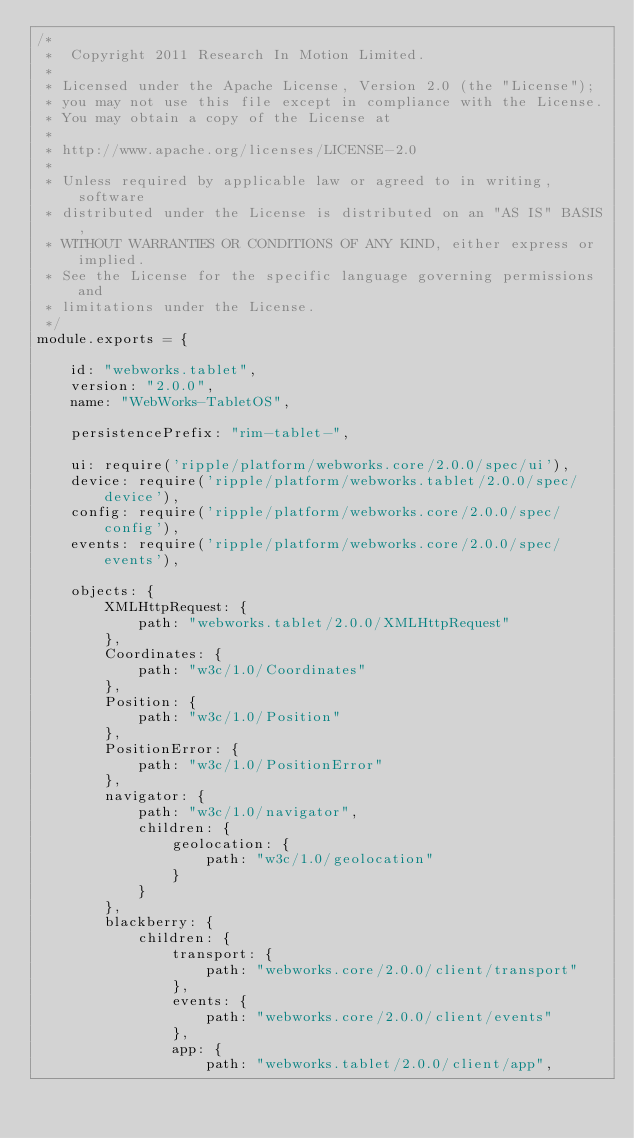Convert code to text. <code><loc_0><loc_0><loc_500><loc_500><_JavaScript_>/*
 *  Copyright 2011 Research In Motion Limited.
 *
 * Licensed under the Apache License, Version 2.0 (the "License");
 * you may not use this file except in compliance with the License.
 * You may obtain a copy of the License at
 *
 * http://www.apache.org/licenses/LICENSE-2.0
 *
 * Unless required by applicable law or agreed to in writing, software
 * distributed under the License is distributed on an "AS IS" BASIS,
 * WITHOUT WARRANTIES OR CONDITIONS OF ANY KIND, either express or implied.
 * See the License for the specific language governing permissions and
 * limitations under the License.
 */
module.exports = {

    id: "webworks.tablet",
    version: "2.0.0",
    name: "WebWorks-TabletOS",

    persistencePrefix: "rim-tablet-",

    ui: require('ripple/platform/webworks.core/2.0.0/spec/ui'),
    device: require('ripple/platform/webworks.tablet/2.0.0/spec/device'),
    config: require('ripple/platform/webworks.core/2.0.0/spec/config'),
    events: require('ripple/platform/webworks.core/2.0.0/spec/events'),

    objects: {
        XMLHttpRequest: {
            path: "webworks.tablet/2.0.0/XMLHttpRequest"
        },
        Coordinates: {
            path: "w3c/1.0/Coordinates"
        },
        Position: {
            path: "w3c/1.0/Position"
        },
        PositionError: {
            path: "w3c/1.0/PositionError"
        },
        navigator: {
            path: "w3c/1.0/navigator",
            children: {
                geolocation: {
                    path: "w3c/1.0/geolocation"
                }
            }
        },
        blackberry: {
            children: {
                transport: {
                    path: "webworks.core/2.0.0/client/transport"
                },
                events: {
                    path: "webworks.core/2.0.0/client/events"
                },
                app: {
                    path: "webworks.tablet/2.0.0/client/app",</code> 